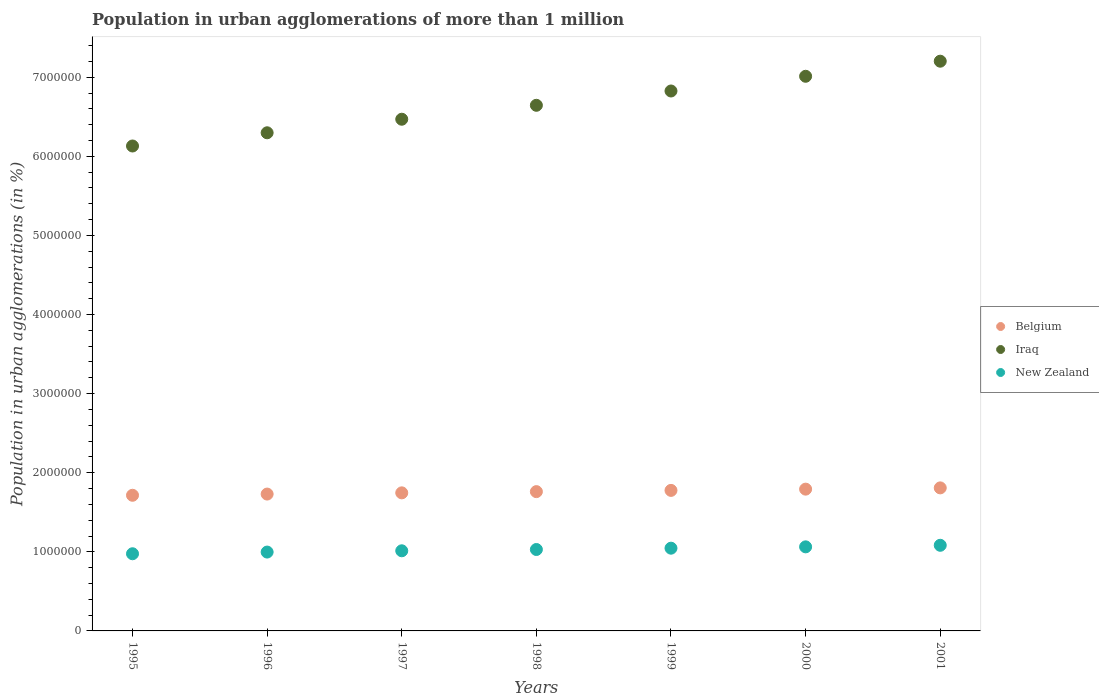Is the number of dotlines equal to the number of legend labels?
Offer a terse response. Yes. What is the population in urban agglomerations in New Zealand in 1999?
Give a very brief answer. 1.05e+06. Across all years, what is the maximum population in urban agglomerations in Belgium?
Keep it short and to the point. 1.81e+06. Across all years, what is the minimum population in urban agglomerations in Iraq?
Make the answer very short. 6.13e+06. In which year was the population in urban agglomerations in Belgium minimum?
Your answer should be compact. 1995. What is the total population in urban agglomerations in Belgium in the graph?
Offer a very short reply. 1.23e+07. What is the difference between the population in urban agglomerations in New Zealand in 1999 and that in 2001?
Your answer should be compact. -3.66e+04. What is the difference between the population in urban agglomerations in New Zealand in 2000 and the population in urban agglomerations in Belgium in 2001?
Provide a short and direct response. -7.45e+05. What is the average population in urban agglomerations in Belgium per year?
Keep it short and to the point. 1.76e+06. In the year 1997, what is the difference between the population in urban agglomerations in Iraq and population in urban agglomerations in Belgium?
Ensure brevity in your answer.  4.72e+06. What is the ratio of the population in urban agglomerations in Iraq in 1997 to that in 2001?
Your response must be concise. 0.9. Is the population in urban agglomerations in Belgium in 1996 less than that in 1998?
Provide a short and direct response. Yes. Is the difference between the population in urban agglomerations in Iraq in 1995 and 1996 greater than the difference between the population in urban agglomerations in Belgium in 1995 and 1996?
Offer a terse response. No. What is the difference between the highest and the second highest population in urban agglomerations in Belgium?
Your answer should be very brief. 1.59e+04. What is the difference between the highest and the lowest population in urban agglomerations in Iraq?
Make the answer very short. 1.07e+06. Is the sum of the population in urban agglomerations in New Zealand in 1996 and 2000 greater than the maximum population in urban agglomerations in Iraq across all years?
Ensure brevity in your answer.  No. Is it the case that in every year, the sum of the population in urban agglomerations in Iraq and population in urban agglomerations in Belgium  is greater than the population in urban agglomerations in New Zealand?
Give a very brief answer. Yes. Is the population in urban agglomerations in New Zealand strictly less than the population in urban agglomerations in Belgium over the years?
Give a very brief answer. Yes. How many years are there in the graph?
Make the answer very short. 7. What is the difference between two consecutive major ticks on the Y-axis?
Provide a short and direct response. 1.00e+06. Does the graph contain any zero values?
Give a very brief answer. No. Does the graph contain grids?
Keep it short and to the point. No. Where does the legend appear in the graph?
Your answer should be very brief. Center right. What is the title of the graph?
Provide a succinct answer. Population in urban agglomerations of more than 1 million. Does "Afghanistan" appear as one of the legend labels in the graph?
Give a very brief answer. No. What is the label or title of the Y-axis?
Make the answer very short. Population in urban agglomerations (in %). What is the Population in urban agglomerations (in %) of Belgium in 1995?
Keep it short and to the point. 1.71e+06. What is the Population in urban agglomerations (in %) in Iraq in 1995?
Offer a terse response. 6.13e+06. What is the Population in urban agglomerations (in %) of New Zealand in 1995?
Make the answer very short. 9.76e+05. What is the Population in urban agglomerations (in %) of Belgium in 1996?
Offer a terse response. 1.73e+06. What is the Population in urban agglomerations (in %) in Iraq in 1996?
Your response must be concise. 6.30e+06. What is the Population in urban agglomerations (in %) in New Zealand in 1996?
Your answer should be very brief. 9.97e+05. What is the Population in urban agglomerations (in %) of Belgium in 1997?
Offer a terse response. 1.75e+06. What is the Population in urban agglomerations (in %) of Iraq in 1997?
Provide a short and direct response. 6.47e+06. What is the Population in urban agglomerations (in %) of New Zealand in 1997?
Offer a very short reply. 1.01e+06. What is the Population in urban agglomerations (in %) in Belgium in 1998?
Your answer should be very brief. 1.76e+06. What is the Population in urban agglomerations (in %) in Iraq in 1998?
Ensure brevity in your answer.  6.65e+06. What is the Population in urban agglomerations (in %) in New Zealand in 1998?
Ensure brevity in your answer.  1.03e+06. What is the Population in urban agglomerations (in %) of Belgium in 1999?
Make the answer very short. 1.78e+06. What is the Population in urban agglomerations (in %) of Iraq in 1999?
Offer a very short reply. 6.83e+06. What is the Population in urban agglomerations (in %) of New Zealand in 1999?
Ensure brevity in your answer.  1.05e+06. What is the Population in urban agglomerations (in %) of Belgium in 2000?
Give a very brief answer. 1.79e+06. What is the Population in urban agglomerations (in %) in Iraq in 2000?
Your answer should be very brief. 7.01e+06. What is the Population in urban agglomerations (in %) in New Zealand in 2000?
Give a very brief answer. 1.06e+06. What is the Population in urban agglomerations (in %) of Belgium in 2001?
Offer a terse response. 1.81e+06. What is the Population in urban agglomerations (in %) of Iraq in 2001?
Your answer should be compact. 7.20e+06. What is the Population in urban agglomerations (in %) of New Zealand in 2001?
Offer a very short reply. 1.08e+06. Across all years, what is the maximum Population in urban agglomerations (in %) in Belgium?
Your answer should be very brief. 1.81e+06. Across all years, what is the maximum Population in urban agglomerations (in %) of Iraq?
Give a very brief answer. 7.20e+06. Across all years, what is the maximum Population in urban agglomerations (in %) of New Zealand?
Make the answer very short. 1.08e+06. Across all years, what is the minimum Population in urban agglomerations (in %) in Belgium?
Your response must be concise. 1.71e+06. Across all years, what is the minimum Population in urban agglomerations (in %) in Iraq?
Your answer should be compact. 6.13e+06. Across all years, what is the minimum Population in urban agglomerations (in %) of New Zealand?
Offer a very short reply. 9.76e+05. What is the total Population in urban agglomerations (in %) of Belgium in the graph?
Offer a very short reply. 1.23e+07. What is the total Population in urban agglomerations (in %) in Iraq in the graph?
Ensure brevity in your answer.  4.66e+07. What is the total Population in urban agglomerations (in %) in New Zealand in the graph?
Ensure brevity in your answer.  7.21e+06. What is the difference between the Population in urban agglomerations (in %) in Belgium in 1995 and that in 1996?
Give a very brief answer. -1.52e+04. What is the difference between the Population in urban agglomerations (in %) of Iraq in 1995 and that in 1996?
Offer a very short reply. -1.67e+05. What is the difference between the Population in urban agglomerations (in %) in New Zealand in 1995 and that in 1996?
Ensure brevity in your answer.  -2.14e+04. What is the difference between the Population in urban agglomerations (in %) in Belgium in 1995 and that in 1997?
Ensure brevity in your answer.  -3.06e+04. What is the difference between the Population in urban agglomerations (in %) of Iraq in 1995 and that in 1997?
Your answer should be very brief. -3.38e+05. What is the difference between the Population in urban agglomerations (in %) in New Zealand in 1995 and that in 1997?
Ensure brevity in your answer.  -3.74e+04. What is the difference between the Population in urban agglomerations (in %) in Belgium in 1995 and that in 1998?
Your answer should be very brief. -4.61e+04. What is the difference between the Population in urban agglomerations (in %) in Iraq in 1995 and that in 1998?
Keep it short and to the point. -5.15e+05. What is the difference between the Population in urban agglomerations (in %) of New Zealand in 1995 and that in 1998?
Give a very brief answer. -5.38e+04. What is the difference between the Population in urban agglomerations (in %) in Belgium in 1995 and that in 1999?
Ensure brevity in your answer.  -6.17e+04. What is the difference between the Population in urban agglomerations (in %) of Iraq in 1995 and that in 1999?
Offer a terse response. -6.95e+05. What is the difference between the Population in urban agglomerations (in %) of New Zealand in 1995 and that in 1999?
Offer a terse response. -7.04e+04. What is the difference between the Population in urban agglomerations (in %) in Belgium in 1995 and that in 2000?
Your answer should be compact. -7.75e+04. What is the difference between the Population in urban agglomerations (in %) in Iraq in 1995 and that in 2000?
Ensure brevity in your answer.  -8.81e+05. What is the difference between the Population in urban agglomerations (in %) of New Zealand in 1995 and that in 2000?
Give a very brief answer. -8.73e+04. What is the difference between the Population in urban agglomerations (in %) in Belgium in 1995 and that in 2001?
Give a very brief answer. -9.34e+04. What is the difference between the Population in urban agglomerations (in %) in Iraq in 1995 and that in 2001?
Provide a succinct answer. -1.07e+06. What is the difference between the Population in urban agglomerations (in %) in New Zealand in 1995 and that in 2001?
Provide a succinct answer. -1.07e+05. What is the difference between the Population in urban agglomerations (in %) of Belgium in 1996 and that in 1997?
Make the answer very short. -1.53e+04. What is the difference between the Population in urban agglomerations (in %) of Iraq in 1996 and that in 1997?
Make the answer very short. -1.71e+05. What is the difference between the Population in urban agglomerations (in %) of New Zealand in 1996 and that in 1997?
Provide a short and direct response. -1.61e+04. What is the difference between the Population in urban agglomerations (in %) in Belgium in 1996 and that in 1998?
Make the answer very short. -3.08e+04. What is the difference between the Population in urban agglomerations (in %) in Iraq in 1996 and that in 1998?
Offer a terse response. -3.47e+05. What is the difference between the Population in urban agglomerations (in %) of New Zealand in 1996 and that in 1998?
Your answer should be very brief. -3.24e+04. What is the difference between the Population in urban agglomerations (in %) in Belgium in 1996 and that in 1999?
Ensure brevity in your answer.  -4.65e+04. What is the difference between the Population in urban agglomerations (in %) in Iraq in 1996 and that in 1999?
Your answer should be compact. -5.28e+05. What is the difference between the Population in urban agglomerations (in %) in New Zealand in 1996 and that in 1999?
Provide a succinct answer. -4.90e+04. What is the difference between the Population in urban agglomerations (in %) of Belgium in 1996 and that in 2000?
Your response must be concise. -6.23e+04. What is the difference between the Population in urban agglomerations (in %) of Iraq in 1996 and that in 2000?
Ensure brevity in your answer.  -7.14e+05. What is the difference between the Population in urban agglomerations (in %) of New Zealand in 1996 and that in 2000?
Ensure brevity in your answer.  -6.59e+04. What is the difference between the Population in urban agglomerations (in %) of Belgium in 1996 and that in 2001?
Your answer should be compact. -7.82e+04. What is the difference between the Population in urban agglomerations (in %) of Iraq in 1996 and that in 2001?
Ensure brevity in your answer.  -9.05e+05. What is the difference between the Population in urban agglomerations (in %) of New Zealand in 1996 and that in 2001?
Keep it short and to the point. -8.56e+04. What is the difference between the Population in urban agglomerations (in %) of Belgium in 1997 and that in 1998?
Your answer should be compact. -1.55e+04. What is the difference between the Population in urban agglomerations (in %) in Iraq in 1997 and that in 1998?
Keep it short and to the point. -1.76e+05. What is the difference between the Population in urban agglomerations (in %) of New Zealand in 1997 and that in 1998?
Offer a terse response. -1.63e+04. What is the difference between the Population in urban agglomerations (in %) in Belgium in 1997 and that in 1999?
Give a very brief answer. -3.11e+04. What is the difference between the Population in urban agglomerations (in %) of Iraq in 1997 and that in 1999?
Your answer should be compact. -3.57e+05. What is the difference between the Population in urban agglomerations (in %) of New Zealand in 1997 and that in 1999?
Offer a terse response. -3.30e+04. What is the difference between the Population in urban agglomerations (in %) in Belgium in 1997 and that in 2000?
Your answer should be compact. -4.69e+04. What is the difference between the Population in urban agglomerations (in %) in Iraq in 1997 and that in 2000?
Provide a succinct answer. -5.43e+05. What is the difference between the Population in urban agglomerations (in %) of New Zealand in 1997 and that in 2000?
Provide a succinct answer. -4.99e+04. What is the difference between the Population in urban agglomerations (in %) of Belgium in 1997 and that in 2001?
Ensure brevity in your answer.  -6.28e+04. What is the difference between the Population in urban agglomerations (in %) of Iraq in 1997 and that in 2001?
Your answer should be very brief. -7.34e+05. What is the difference between the Population in urban agglomerations (in %) of New Zealand in 1997 and that in 2001?
Your answer should be compact. -6.96e+04. What is the difference between the Population in urban agglomerations (in %) of Belgium in 1998 and that in 1999?
Ensure brevity in your answer.  -1.56e+04. What is the difference between the Population in urban agglomerations (in %) in Iraq in 1998 and that in 1999?
Provide a succinct answer. -1.81e+05. What is the difference between the Population in urban agglomerations (in %) in New Zealand in 1998 and that in 1999?
Your answer should be compact. -1.66e+04. What is the difference between the Population in urban agglomerations (in %) of Belgium in 1998 and that in 2000?
Your answer should be compact. -3.14e+04. What is the difference between the Population in urban agglomerations (in %) in Iraq in 1998 and that in 2000?
Provide a succinct answer. -3.67e+05. What is the difference between the Population in urban agglomerations (in %) in New Zealand in 1998 and that in 2000?
Offer a terse response. -3.35e+04. What is the difference between the Population in urban agglomerations (in %) of Belgium in 1998 and that in 2001?
Your answer should be compact. -4.73e+04. What is the difference between the Population in urban agglomerations (in %) in Iraq in 1998 and that in 2001?
Keep it short and to the point. -5.58e+05. What is the difference between the Population in urban agglomerations (in %) in New Zealand in 1998 and that in 2001?
Your answer should be compact. -5.32e+04. What is the difference between the Population in urban agglomerations (in %) in Belgium in 1999 and that in 2000?
Ensure brevity in your answer.  -1.58e+04. What is the difference between the Population in urban agglomerations (in %) in Iraq in 1999 and that in 2000?
Offer a terse response. -1.86e+05. What is the difference between the Population in urban agglomerations (in %) of New Zealand in 1999 and that in 2000?
Provide a succinct answer. -1.69e+04. What is the difference between the Population in urban agglomerations (in %) in Belgium in 1999 and that in 2001?
Provide a succinct answer. -3.17e+04. What is the difference between the Population in urban agglomerations (in %) of Iraq in 1999 and that in 2001?
Your response must be concise. -3.77e+05. What is the difference between the Population in urban agglomerations (in %) of New Zealand in 1999 and that in 2001?
Provide a succinct answer. -3.66e+04. What is the difference between the Population in urban agglomerations (in %) of Belgium in 2000 and that in 2001?
Provide a succinct answer. -1.59e+04. What is the difference between the Population in urban agglomerations (in %) in Iraq in 2000 and that in 2001?
Offer a very short reply. -1.91e+05. What is the difference between the Population in urban agglomerations (in %) in New Zealand in 2000 and that in 2001?
Ensure brevity in your answer.  -1.97e+04. What is the difference between the Population in urban agglomerations (in %) in Belgium in 1995 and the Population in urban agglomerations (in %) in Iraq in 1996?
Keep it short and to the point. -4.58e+06. What is the difference between the Population in urban agglomerations (in %) of Belgium in 1995 and the Population in urban agglomerations (in %) of New Zealand in 1996?
Provide a short and direct response. 7.18e+05. What is the difference between the Population in urban agglomerations (in %) in Iraq in 1995 and the Population in urban agglomerations (in %) in New Zealand in 1996?
Ensure brevity in your answer.  5.13e+06. What is the difference between the Population in urban agglomerations (in %) in Belgium in 1995 and the Population in urban agglomerations (in %) in Iraq in 1997?
Keep it short and to the point. -4.75e+06. What is the difference between the Population in urban agglomerations (in %) in Belgium in 1995 and the Population in urban agglomerations (in %) in New Zealand in 1997?
Keep it short and to the point. 7.02e+05. What is the difference between the Population in urban agglomerations (in %) in Iraq in 1995 and the Population in urban agglomerations (in %) in New Zealand in 1997?
Offer a terse response. 5.12e+06. What is the difference between the Population in urban agglomerations (in %) of Belgium in 1995 and the Population in urban agglomerations (in %) of Iraq in 1998?
Keep it short and to the point. -4.93e+06. What is the difference between the Population in urban agglomerations (in %) in Belgium in 1995 and the Population in urban agglomerations (in %) in New Zealand in 1998?
Offer a terse response. 6.86e+05. What is the difference between the Population in urban agglomerations (in %) in Iraq in 1995 and the Population in urban agglomerations (in %) in New Zealand in 1998?
Offer a terse response. 5.10e+06. What is the difference between the Population in urban agglomerations (in %) in Belgium in 1995 and the Population in urban agglomerations (in %) in Iraq in 1999?
Your answer should be compact. -5.11e+06. What is the difference between the Population in urban agglomerations (in %) of Belgium in 1995 and the Population in urban agglomerations (in %) of New Zealand in 1999?
Provide a short and direct response. 6.69e+05. What is the difference between the Population in urban agglomerations (in %) of Iraq in 1995 and the Population in urban agglomerations (in %) of New Zealand in 1999?
Your answer should be compact. 5.08e+06. What is the difference between the Population in urban agglomerations (in %) of Belgium in 1995 and the Population in urban agglomerations (in %) of Iraq in 2000?
Your answer should be very brief. -5.30e+06. What is the difference between the Population in urban agglomerations (in %) of Belgium in 1995 and the Population in urban agglomerations (in %) of New Zealand in 2000?
Your answer should be very brief. 6.52e+05. What is the difference between the Population in urban agglomerations (in %) of Iraq in 1995 and the Population in urban agglomerations (in %) of New Zealand in 2000?
Your answer should be compact. 5.07e+06. What is the difference between the Population in urban agglomerations (in %) in Belgium in 1995 and the Population in urban agglomerations (in %) in Iraq in 2001?
Your answer should be compact. -5.49e+06. What is the difference between the Population in urban agglomerations (in %) in Belgium in 1995 and the Population in urban agglomerations (in %) in New Zealand in 2001?
Your answer should be compact. 6.32e+05. What is the difference between the Population in urban agglomerations (in %) of Iraq in 1995 and the Population in urban agglomerations (in %) of New Zealand in 2001?
Keep it short and to the point. 5.05e+06. What is the difference between the Population in urban agglomerations (in %) of Belgium in 1996 and the Population in urban agglomerations (in %) of Iraq in 1997?
Your response must be concise. -4.74e+06. What is the difference between the Population in urban agglomerations (in %) of Belgium in 1996 and the Population in urban agglomerations (in %) of New Zealand in 1997?
Your response must be concise. 7.17e+05. What is the difference between the Population in urban agglomerations (in %) of Iraq in 1996 and the Population in urban agglomerations (in %) of New Zealand in 1997?
Keep it short and to the point. 5.28e+06. What is the difference between the Population in urban agglomerations (in %) in Belgium in 1996 and the Population in urban agglomerations (in %) in Iraq in 1998?
Offer a very short reply. -4.92e+06. What is the difference between the Population in urban agglomerations (in %) in Belgium in 1996 and the Population in urban agglomerations (in %) in New Zealand in 1998?
Your answer should be compact. 7.01e+05. What is the difference between the Population in urban agglomerations (in %) in Iraq in 1996 and the Population in urban agglomerations (in %) in New Zealand in 1998?
Ensure brevity in your answer.  5.27e+06. What is the difference between the Population in urban agglomerations (in %) of Belgium in 1996 and the Population in urban agglomerations (in %) of Iraq in 1999?
Keep it short and to the point. -5.10e+06. What is the difference between the Population in urban agglomerations (in %) in Belgium in 1996 and the Population in urban agglomerations (in %) in New Zealand in 1999?
Provide a succinct answer. 6.84e+05. What is the difference between the Population in urban agglomerations (in %) in Iraq in 1996 and the Population in urban agglomerations (in %) in New Zealand in 1999?
Ensure brevity in your answer.  5.25e+06. What is the difference between the Population in urban agglomerations (in %) of Belgium in 1996 and the Population in urban agglomerations (in %) of Iraq in 2000?
Keep it short and to the point. -5.28e+06. What is the difference between the Population in urban agglomerations (in %) of Belgium in 1996 and the Population in urban agglomerations (in %) of New Zealand in 2000?
Offer a terse response. 6.67e+05. What is the difference between the Population in urban agglomerations (in %) of Iraq in 1996 and the Population in urban agglomerations (in %) of New Zealand in 2000?
Provide a short and direct response. 5.24e+06. What is the difference between the Population in urban agglomerations (in %) in Belgium in 1996 and the Population in urban agglomerations (in %) in Iraq in 2001?
Give a very brief answer. -5.47e+06. What is the difference between the Population in urban agglomerations (in %) in Belgium in 1996 and the Population in urban agglomerations (in %) in New Zealand in 2001?
Keep it short and to the point. 6.48e+05. What is the difference between the Population in urban agglomerations (in %) in Iraq in 1996 and the Population in urban agglomerations (in %) in New Zealand in 2001?
Give a very brief answer. 5.22e+06. What is the difference between the Population in urban agglomerations (in %) in Belgium in 1997 and the Population in urban agglomerations (in %) in Iraq in 1998?
Your answer should be compact. -4.90e+06. What is the difference between the Population in urban agglomerations (in %) of Belgium in 1997 and the Population in urban agglomerations (in %) of New Zealand in 1998?
Provide a succinct answer. 7.16e+05. What is the difference between the Population in urban agglomerations (in %) in Iraq in 1997 and the Population in urban agglomerations (in %) in New Zealand in 1998?
Your answer should be compact. 5.44e+06. What is the difference between the Population in urban agglomerations (in %) of Belgium in 1997 and the Population in urban agglomerations (in %) of Iraq in 1999?
Your response must be concise. -5.08e+06. What is the difference between the Population in urban agglomerations (in %) in Belgium in 1997 and the Population in urban agglomerations (in %) in New Zealand in 1999?
Ensure brevity in your answer.  7.00e+05. What is the difference between the Population in urban agglomerations (in %) of Iraq in 1997 and the Population in urban agglomerations (in %) of New Zealand in 1999?
Provide a succinct answer. 5.42e+06. What is the difference between the Population in urban agglomerations (in %) in Belgium in 1997 and the Population in urban agglomerations (in %) in Iraq in 2000?
Your response must be concise. -5.27e+06. What is the difference between the Population in urban agglomerations (in %) in Belgium in 1997 and the Population in urban agglomerations (in %) in New Zealand in 2000?
Your answer should be very brief. 6.83e+05. What is the difference between the Population in urban agglomerations (in %) in Iraq in 1997 and the Population in urban agglomerations (in %) in New Zealand in 2000?
Ensure brevity in your answer.  5.41e+06. What is the difference between the Population in urban agglomerations (in %) of Belgium in 1997 and the Population in urban agglomerations (in %) of Iraq in 2001?
Provide a short and direct response. -5.46e+06. What is the difference between the Population in urban agglomerations (in %) of Belgium in 1997 and the Population in urban agglomerations (in %) of New Zealand in 2001?
Provide a short and direct response. 6.63e+05. What is the difference between the Population in urban agglomerations (in %) of Iraq in 1997 and the Population in urban agglomerations (in %) of New Zealand in 2001?
Your answer should be very brief. 5.39e+06. What is the difference between the Population in urban agglomerations (in %) in Belgium in 1998 and the Population in urban agglomerations (in %) in Iraq in 1999?
Make the answer very short. -5.07e+06. What is the difference between the Population in urban agglomerations (in %) of Belgium in 1998 and the Population in urban agglomerations (in %) of New Zealand in 1999?
Give a very brief answer. 7.15e+05. What is the difference between the Population in urban agglomerations (in %) in Iraq in 1998 and the Population in urban agglomerations (in %) in New Zealand in 1999?
Offer a terse response. 5.60e+06. What is the difference between the Population in urban agglomerations (in %) in Belgium in 1998 and the Population in urban agglomerations (in %) in Iraq in 2000?
Your response must be concise. -5.25e+06. What is the difference between the Population in urban agglomerations (in %) of Belgium in 1998 and the Population in urban agglomerations (in %) of New Zealand in 2000?
Offer a terse response. 6.98e+05. What is the difference between the Population in urban agglomerations (in %) of Iraq in 1998 and the Population in urban agglomerations (in %) of New Zealand in 2000?
Your response must be concise. 5.58e+06. What is the difference between the Population in urban agglomerations (in %) of Belgium in 1998 and the Population in urban agglomerations (in %) of Iraq in 2001?
Offer a terse response. -5.44e+06. What is the difference between the Population in urban agglomerations (in %) of Belgium in 1998 and the Population in urban agglomerations (in %) of New Zealand in 2001?
Give a very brief answer. 6.78e+05. What is the difference between the Population in urban agglomerations (in %) in Iraq in 1998 and the Population in urban agglomerations (in %) in New Zealand in 2001?
Your answer should be very brief. 5.56e+06. What is the difference between the Population in urban agglomerations (in %) of Belgium in 1999 and the Population in urban agglomerations (in %) of Iraq in 2000?
Ensure brevity in your answer.  -5.24e+06. What is the difference between the Population in urban agglomerations (in %) in Belgium in 1999 and the Population in urban agglomerations (in %) in New Zealand in 2000?
Your answer should be compact. 7.14e+05. What is the difference between the Population in urban agglomerations (in %) in Iraq in 1999 and the Population in urban agglomerations (in %) in New Zealand in 2000?
Give a very brief answer. 5.76e+06. What is the difference between the Population in urban agglomerations (in %) in Belgium in 1999 and the Population in urban agglomerations (in %) in Iraq in 2001?
Give a very brief answer. -5.43e+06. What is the difference between the Population in urban agglomerations (in %) in Belgium in 1999 and the Population in urban agglomerations (in %) in New Zealand in 2001?
Ensure brevity in your answer.  6.94e+05. What is the difference between the Population in urban agglomerations (in %) of Iraq in 1999 and the Population in urban agglomerations (in %) of New Zealand in 2001?
Provide a succinct answer. 5.74e+06. What is the difference between the Population in urban agglomerations (in %) of Belgium in 2000 and the Population in urban agglomerations (in %) of Iraq in 2001?
Offer a terse response. -5.41e+06. What is the difference between the Population in urban agglomerations (in %) in Belgium in 2000 and the Population in urban agglomerations (in %) in New Zealand in 2001?
Your answer should be compact. 7.10e+05. What is the difference between the Population in urban agglomerations (in %) of Iraq in 2000 and the Population in urban agglomerations (in %) of New Zealand in 2001?
Give a very brief answer. 5.93e+06. What is the average Population in urban agglomerations (in %) of Belgium per year?
Offer a terse response. 1.76e+06. What is the average Population in urban agglomerations (in %) of Iraq per year?
Your answer should be very brief. 6.65e+06. What is the average Population in urban agglomerations (in %) in New Zealand per year?
Offer a terse response. 1.03e+06. In the year 1995, what is the difference between the Population in urban agglomerations (in %) in Belgium and Population in urban agglomerations (in %) in Iraq?
Give a very brief answer. -4.42e+06. In the year 1995, what is the difference between the Population in urban agglomerations (in %) of Belgium and Population in urban agglomerations (in %) of New Zealand?
Your response must be concise. 7.39e+05. In the year 1995, what is the difference between the Population in urban agglomerations (in %) of Iraq and Population in urban agglomerations (in %) of New Zealand?
Your answer should be compact. 5.16e+06. In the year 1996, what is the difference between the Population in urban agglomerations (in %) of Belgium and Population in urban agglomerations (in %) of Iraq?
Your response must be concise. -4.57e+06. In the year 1996, what is the difference between the Population in urban agglomerations (in %) of Belgium and Population in urban agglomerations (in %) of New Zealand?
Ensure brevity in your answer.  7.33e+05. In the year 1996, what is the difference between the Population in urban agglomerations (in %) in Iraq and Population in urban agglomerations (in %) in New Zealand?
Your answer should be compact. 5.30e+06. In the year 1997, what is the difference between the Population in urban agglomerations (in %) of Belgium and Population in urban agglomerations (in %) of Iraq?
Your response must be concise. -4.72e+06. In the year 1997, what is the difference between the Population in urban agglomerations (in %) of Belgium and Population in urban agglomerations (in %) of New Zealand?
Make the answer very short. 7.33e+05. In the year 1997, what is the difference between the Population in urban agglomerations (in %) in Iraq and Population in urban agglomerations (in %) in New Zealand?
Offer a terse response. 5.46e+06. In the year 1998, what is the difference between the Population in urban agglomerations (in %) in Belgium and Population in urban agglomerations (in %) in Iraq?
Provide a succinct answer. -4.88e+06. In the year 1998, what is the difference between the Population in urban agglomerations (in %) of Belgium and Population in urban agglomerations (in %) of New Zealand?
Keep it short and to the point. 7.32e+05. In the year 1998, what is the difference between the Population in urban agglomerations (in %) of Iraq and Population in urban agglomerations (in %) of New Zealand?
Provide a succinct answer. 5.62e+06. In the year 1999, what is the difference between the Population in urban agglomerations (in %) of Belgium and Population in urban agglomerations (in %) of Iraq?
Offer a terse response. -5.05e+06. In the year 1999, what is the difference between the Population in urban agglomerations (in %) of Belgium and Population in urban agglomerations (in %) of New Zealand?
Offer a terse response. 7.31e+05. In the year 1999, what is the difference between the Population in urban agglomerations (in %) in Iraq and Population in urban agglomerations (in %) in New Zealand?
Provide a short and direct response. 5.78e+06. In the year 2000, what is the difference between the Population in urban agglomerations (in %) of Belgium and Population in urban agglomerations (in %) of Iraq?
Ensure brevity in your answer.  -5.22e+06. In the year 2000, what is the difference between the Population in urban agglomerations (in %) in Belgium and Population in urban agglomerations (in %) in New Zealand?
Provide a succinct answer. 7.30e+05. In the year 2000, what is the difference between the Population in urban agglomerations (in %) of Iraq and Population in urban agglomerations (in %) of New Zealand?
Ensure brevity in your answer.  5.95e+06. In the year 2001, what is the difference between the Population in urban agglomerations (in %) of Belgium and Population in urban agglomerations (in %) of Iraq?
Offer a terse response. -5.39e+06. In the year 2001, what is the difference between the Population in urban agglomerations (in %) of Belgium and Population in urban agglomerations (in %) of New Zealand?
Provide a succinct answer. 7.26e+05. In the year 2001, what is the difference between the Population in urban agglomerations (in %) in Iraq and Population in urban agglomerations (in %) in New Zealand?
Provide a short and direct response. 6.12e+06. What is the ratio of the Population in urban agglomerations (in %) of Iraq in 1995 to that in 1996?
Your answer should be compact. 0.97. What is the ratio of the Population in urban agglomerations (in %) of New Zealand in 1995 to that in 1996?
Make the answer very short. 0.98. What is the ratio of the Population in urban agglomerations (in %) of Belgium in 1995 to that in 1997?
Offer a terse response. 0.98. What is the ratio of the Population in urban agglomerations (in %) in Iraq in 1995 to that in 1997?
Provide a short and direct response. 0.95. What is the ratio of the Population in urban agglomerations (in %) of New Zealand in 1995 to that in 1997?
Your answer should be compact. 0.96. What is the ratio of the Population in urban agglomerations (in %) in Belgium in 1995 to that in 1998?
Keep it short and to the point. 0.97. What is the ratio of the Population in urban agglomerations (in %) of Iraq in 1995 to that in 1998?
Your answer should be very brief. 0.92. What is the ratio of the Population in urban agglomerations (in %) of New Zealand in 1995 to that in 1998?
Your answer should be very brief. 0.95. What is the ratio of the Population in urban agglomerations (in %) in Belgium in 1995 to that in 1999?
Give a very brief answer. 0.97. What is the ratio of the Population in urban agglomerations (in %) in Iraq in 1995 to that in 1999?
Ensure brevity in your answer.  0.9. What is the ratio of the Population in urban agglomerations (in %) of New Zealand in 1995 to that in 1999?
Your answer should be compact. 0.93. What is the ratio of the Population in urban agglomerations (in %) in Belgium in 1995 to that in 2000?
Provide a succinct answer. 0.96. What is the ratio of the Population in urban agglomerations (in %) of Iraq in 1995 to that in 2000?
Make the answer very short. 0.87. What is the ratio of the Population in urban agglomerations (in %) of New Zealand in 1995 to that in 2000?
Keep it short and to the point. 0.92. What is the ratio of the Population in urban agglomerations (in %) of Belgium in 1995 to that in 2001?
Make the answer very short. 0.95. What is the ratio of the Population in urban agglomerations (in %) in Iraq in 1995 to that in 2001?
Your answer should be very brief. 0.85. What is the ratio of the Population in urban agglomerations (in %) of New Zealand in 1995 to that in 2001?
Keep it short and to the point. 0.9. What is the ratio of the Population in urban agglomerations (in %) of Iraq in 1996 to that in 1997?
Keep it short and to the point. 0.97. What is the ratio of the Population in urban agglomerations (in %) of New Zealand in 1996 to that in 1997?
Give a very brief answer. 0.98. What is the ratio of the Population in urban agglomerations (in %) in Belgium in 1996 to that in 1998?
Offer a very short reply. 0.98. What is the ratio of the Population in urban agglomerations (in %) of Iraq in 1996 to that in 1998?
Offer a terse response. 0.95. What is the ratio of the Population in urban agglomerations (in %) in New Zealand in 1996 to that in 1998?
Offer a terse response. 0.97. What is the ratio of the Population in urban agglomerations (in %) of Belgium in 1996 to that in 1999?
Your response must be concise. 0.97. What is the ratio of the Population in urban agglomerations (in %) in Iraq in 1996 to that in 1999?
Your response must be concise. 0.92. What is the ratio of the Population in urban agglomerations (in %) in New Zealand in 1996 to that in 1999?
Your answer should be compact. 0.95. What is the ratio of the Population in urban agglomerations (in %) in Belgium in 1996 to that in 2000?
Ensure brevity in your answer.  0.97. What is the ratio of the Population in urban agglomerations (in %) in Iraq in 1996 to that in 2000?
Provide a succinct answer. 0.9. What is the ratio of the Population in urban agglomerations (in %) in New Zealand in 1996 to that in 2000?
Offer a terse response. 0.94. What is the ratio of the Population in urban agglomerations (in %) of Belgium in 1996 to that in 2001?
Offer a very short reply. 0.96. What is the ratio of the Population in urban agglomerations (in %) in Iraq in 1996 to that in 2001?
Ensure brevity in your answer.  0.87. What is the ratio of the Population in urban agglomerations (in %) in New Zealand in 1996 to that in 2001?
Make the answer very short. 0.92. What is the ratio of the Population in urban agglomerations (in %) in Belgium in 1997 to that in 1998?
Make the answer very short. 0.99. What is the ratio of the Population in urban agglomerations (in %) of Iraq in 1997 to that in 1998?
Your response must be concise. 0.97. What is the ratio of the Population in urban agglomerations (in %) of New Zealand in 1997 to that in 1998?
Your response must be concise. 0.98. What is the ratio of the Population in urban agglomerations (in %) in Belgium in 1997 to that in 1999?
Keep it short and to the point. 0.98. What is the ratio of the Population in urban agglomerations (in %) in Iraq in 1997 to that in 1999?
Your response must be concise. 0.95. What is the ratio of the Population in urban agglomerations (in %) of New Zealand in 1997 to that in 1999?
Your answer should be compact. 0.97. What is the ratio of the Population in urban agglomerations (in %) in Belgium in 1997 to that in 2000?
Make the answer very short. 0.97. What is the ratio of the Population in urban agglomerations (in %) of Iraq in 1997 to that in 2000?
Your answer should be very brief. 0.92. What is the ratio of the Population in urban agglomerations (in %) of New Zealand in 1997 to that in 2000?
Keep it short and to the point. 0.95. What is the ratio of the Population in urban agglomerations (in %) of Belgium in 1997 to that in 2001?
Your answer should be compact. 0.97. What is the ratio of the Population in urban agglomerations (in %) of Iraq in 1997 to that in 2001?
Your response must be concise. 0.9. What is the ratio of the Population in urban agglomerations (in %) of New Zealand in 1997 to that in 2001?
Your answer should be compact. 0.94. What is the ratio of the Population in urban agglomerations (in %) in Iraq in 1998 to that in 1999?
Your answer should be compact. 0.97. What is the ratio of the Population in urban agglomerations (in %) of New Zealand in 1998 to that in 1999?
Your answer should be compact. 0.98. What is the ratio of the Population in urban agglomerations (in %) of Belgium in 1998 to that in 2000?
Provide a short and direct response. 0.98. What is the ratio of the Population in urban agglomerations (in %) of Iraq in 1998 to that in 2000?
Your response must be concise. 0.95. What is the ratio of the Population in urban agglomerations (in %) of New Zealand in 1998 to that in 2000?
Offer a very short reply. 0.97. What is the ratio of the Population in urban agglomerations (in %) in Belgium in 1998 to that in 2001?
Offer a terse response. 0.97. What is the ratio of the Population in urban agglomerations (in %) of Iraq in 1998 to that in 2001?
Provide a short and direct response. 0.92. What is the ratio of the Population in urban agglomerations (in %) of New Zealand in 1998 to that in 2001?
Ensure brevity in your answer.  0.95. What is the ratio of the Population in urban agglomerations (in %) in Iraq in 1999 to that in 2000?
Make the answer very short. 0.97. What is the ratio of the Population in urban agglomerations (in %) in New Zealand in 1999 to that in 2000?
Offer a very short reply. 0.98. What is the ratio of the Population in urban agglomerations (in %) in Belgium in 1999 to that in 2001?
Offer a very short reply. 0.98. What is the ratio of the Population in urban agglomerations (in %) in Iraq in 1999 to that in 2001?
Offer a terse response. 0.95. What is the ratio of the Population in urban agglomerations (in %) in New Zealand in 1999 to that in 2001?
Offer a very short reply. 0.97. What is the ratio of the Population in urban agglomerations (in %) in Belgium in 2000 to that in 2001?
Keep it short and to the point. 0.99. What is the ratio of the Population in urban agglomerations (in %) of Iraq in 2000 to that in 2001?
Provide a short and direct response. 0.97. What is the ratio of the Population in urban agglomerations (in %) of New Zealand in 2000 to that in 2001?
Your answer should be very brief. 0.98. What is the difference between the highest and the second highest Population in urban agglomerations (in %) of Belgium?
Provide a short and direct response. 1.59e+04. What is the difference between the highest and the second highest Population in urban agglomerations (in %) in Iraq?
Ensure brevity in your answer.  1.91e+05. What is the difference between the highest and the second highest Population in urban agglomerations (in %) of New Zealand?
Make the answer very short. 1.97e+04. What is the difference between the highest and the lowest Population in urban agglomerations (in %) of Belgium?
Provide a short and direct response. 9.34e+04. What is the difference between the highest and the lowest Population in urban agglomerations (in %) of Iraq?
Provide a short and direct response. 1.07e+06. What is the difference between the highest and the lowest Population in urban agglomerations (in %) in New Zealand?
Provide a short and direct response. 1.07e+05. 